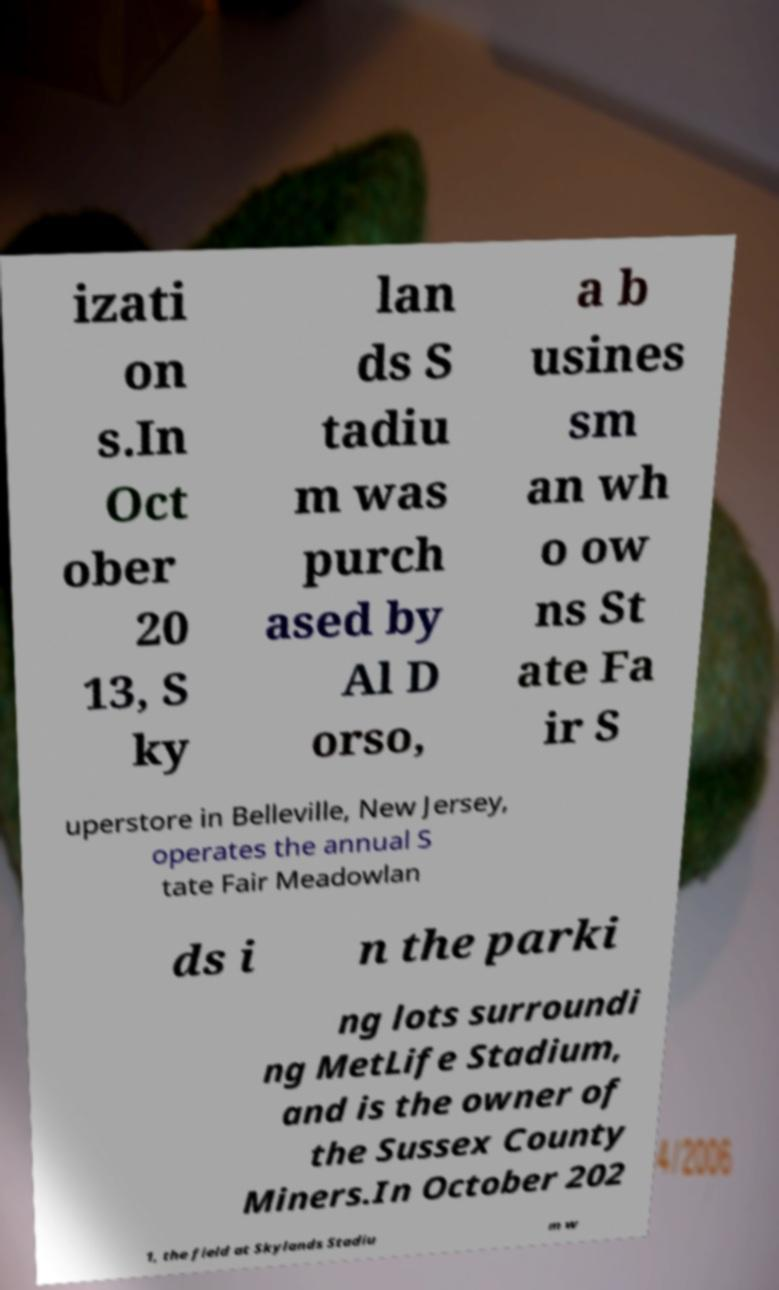I need the written content from this picture converted into text. Can you do that? izati on s.In Oct ober 20 13, S ky lan ds S tadiu m was purch ased by Al D orso, a b usines sm an wh o ow ns St ate Fa ir S uperstore in Belleville, New Jersey, operates the annual S tate Fair Meadowlan ds i n the parki ng lots surroundi ng MetLife Stadium, and is the owner of the Sussex County Miners.In October 202 1, the field at Skylands Stadiu m w 